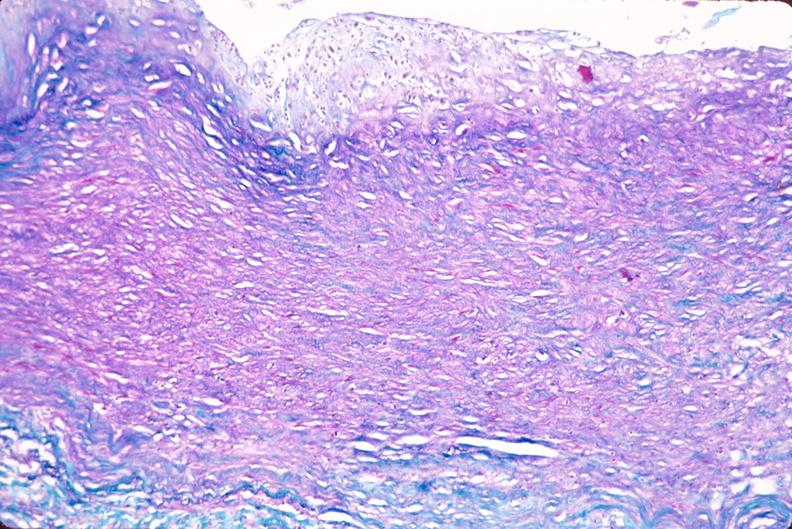does this image show saphenous vein graft sclerosis?
Answer the question using a single word or phrase. Yes 